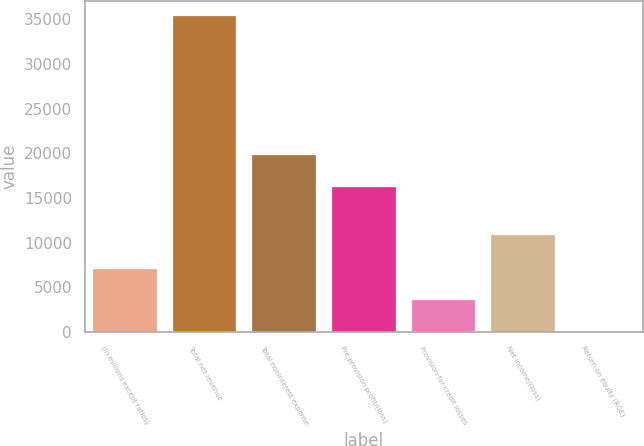Convert chart. <chart><loc_0><loc_0><loc_500><loc_500><bar_chart><fcel>(in millions except ratios)<fcel>Total net revenue<fcel>Total noninterest expense<fcel>Pre-provision profit/(loss)<fcel>Provision for credit losses<fcel>Net income/(loss)<fcel>Return on equity (ROE)<nl><fcel>7080.8<fcel>35340<fcel>19756.4<fcel>16224<fcel>3548.4<fcel>10815<fcel>16<nl></chart> 